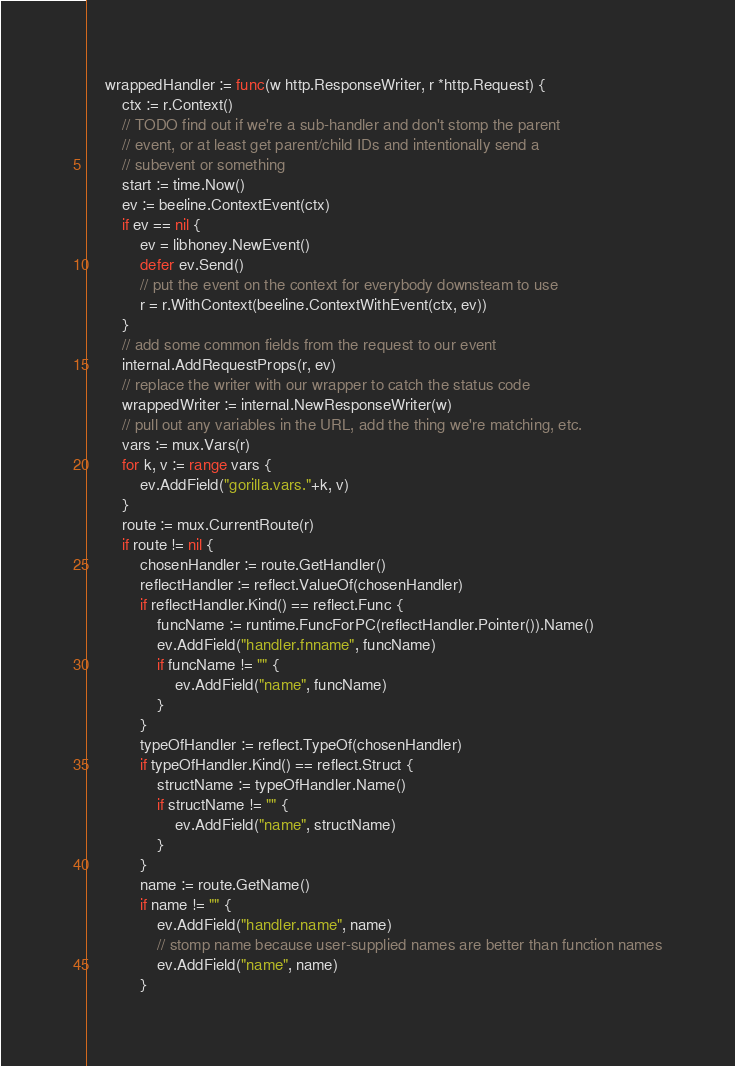Convert code to text. <code><loc_0><loc_0><loc_500><loc_500><_Go_>	wrappedHandler := func(w http.ResponseWriter, r *http.Request) {
		ctx := r.Context()
		// TODO find out if we're a sub-handler and don't stomp the parent
		// event, or at least get parent/child IDs and intentionally send a
		// subevent or something
		start := time.Now()
		ev := beeline.ContextEvent(ctx)
		if ev == nil {
			ev = libhoney.NewEvent()
			defer ev.Send()
			// put the event on the context for everybody downsteam to use
			r = r.WithContext(beeline.ContextWithEvent(ctx, ev))
		}
		// add some common fields from the request to our event
		internal.AddRequestProps(r, ev)
		// replace the writer with our wrapper to catch the status code
		wrappedWriter := internal.NewResponseWriter(w)
		// pull out any variables in the URL, add the thing we're matching, etc.
		vars := mux.Vars(r)
		for k, v := range vars {
			ev.AddField("gorilla.vars."+k, v)
		}
		route := mux.CurrentRoute(r)
		if route != nil {
			chosenHandler := route.GetHandler()
			reflectHandler := reflect.ValueOf(chosenHandler)
			if reflectHandler.Kind() == reflect.Func {
				funcName := runtime.FuncForPC(reflectHandler.Pointer()).Name()
				ev.AddField("handler.fnname", funcName)
				if funcName != "" {
					ev.AddField("name", funcName)
				}
			}
			typeOfHandler := reflect.TypeOf(chosenHandler)
			if typeOfHandler.Kind() == reflect.Struct {
				structName := typeOfHandler.Name()
				if structName != "" {
					ev.AddField("name", structName)
				}
			}
			name := route.GetName()
			if name != "" {
				ev.AddField("handler.name", name)
				// stomp name because user-supplied names are better than function names
				ev.AddField("name", name)
			}</code> 